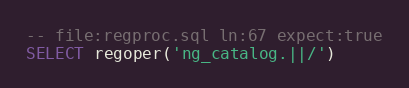<code> <loc_0><loc_0><loc_500><loc_500><_SQL_>-- file:regproc.sql ln:67 expect:true
SELECT regoper('ng_catalog.||/')
</code> 